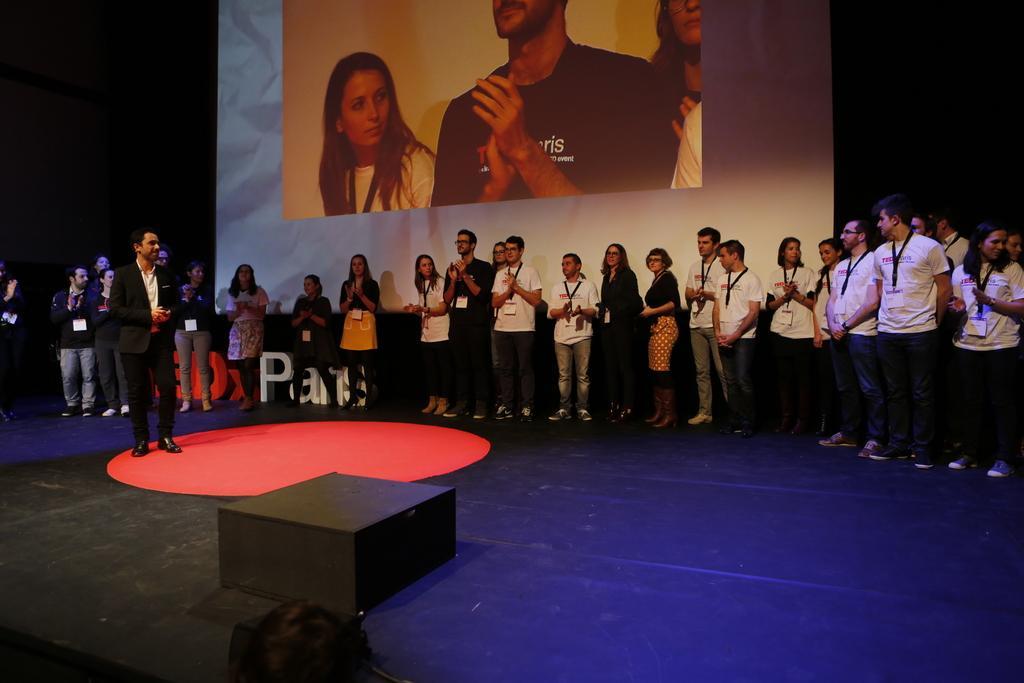How would you summarize this image in a sentence or two? In this picture in the front there are objects which are black in colour. In the background there are persons standing and there is some text written on the board behind the persons, there is a screen with the image of the persons. 